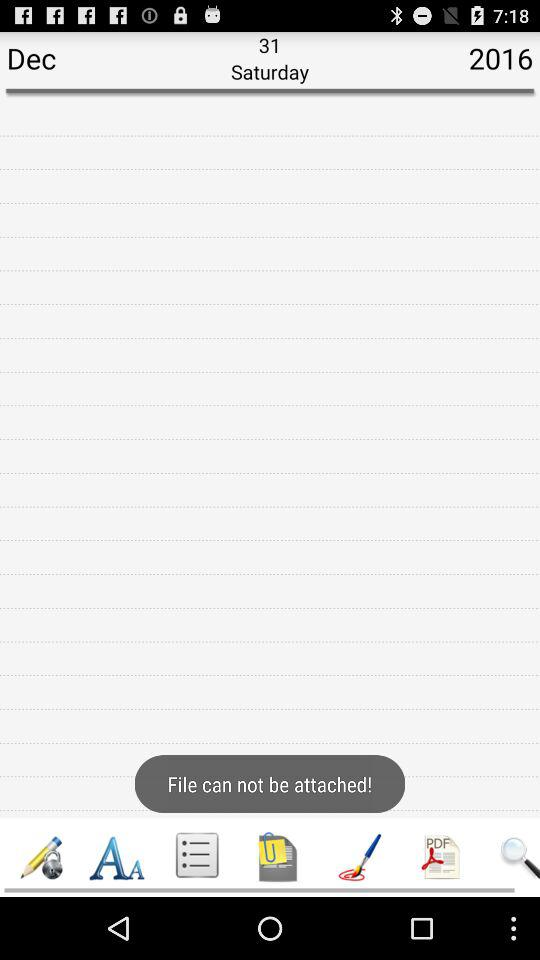What day falls on December 31st, 2016? The day is Saturday. 